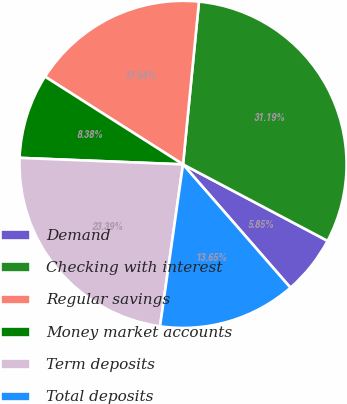Convert chart to OTSL. <chart><loc_0><loc_0><loc_500><loc_500><pie_chart><fcel>Demand<fcel>Checking with interest<fcel>Regular savings<fcel>Money market accounts<fcel>Term deposits<fcel>Total deposits<nl><fcel>5.85%<fcel>31.19%<fcel>17.54%<fcel>8.38%<fcel>23.39%<fcel>13.65%<nl></chart> 